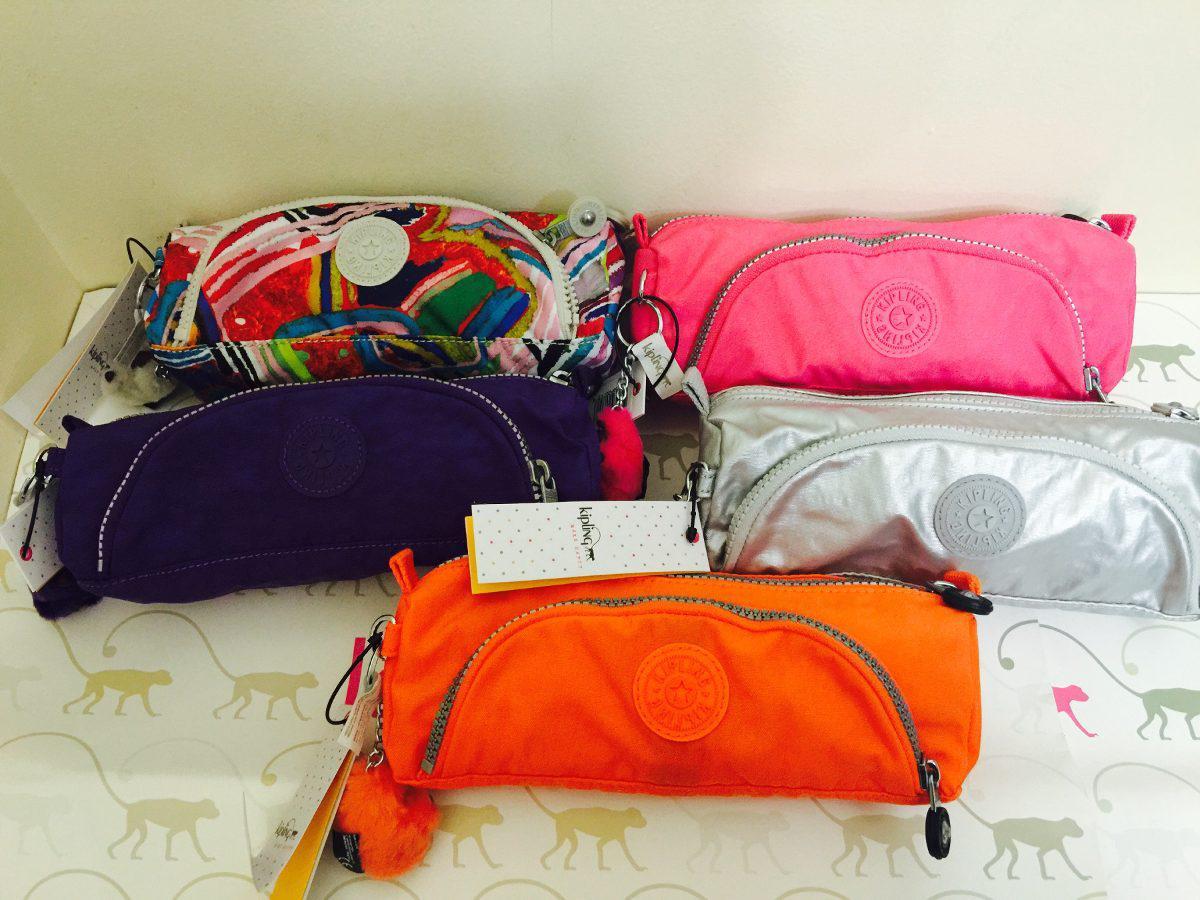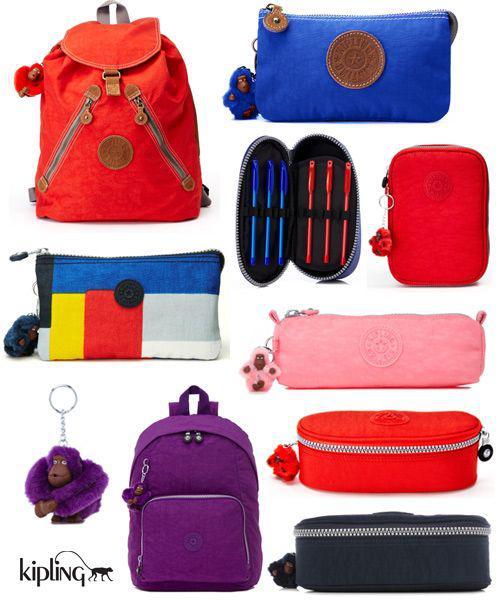The first image is the image on the left, the second image is the image on the right. For the images displayed, is the sentence "A blue pencil case is holding several pencils." factually correct? Answer yes or no. No. 